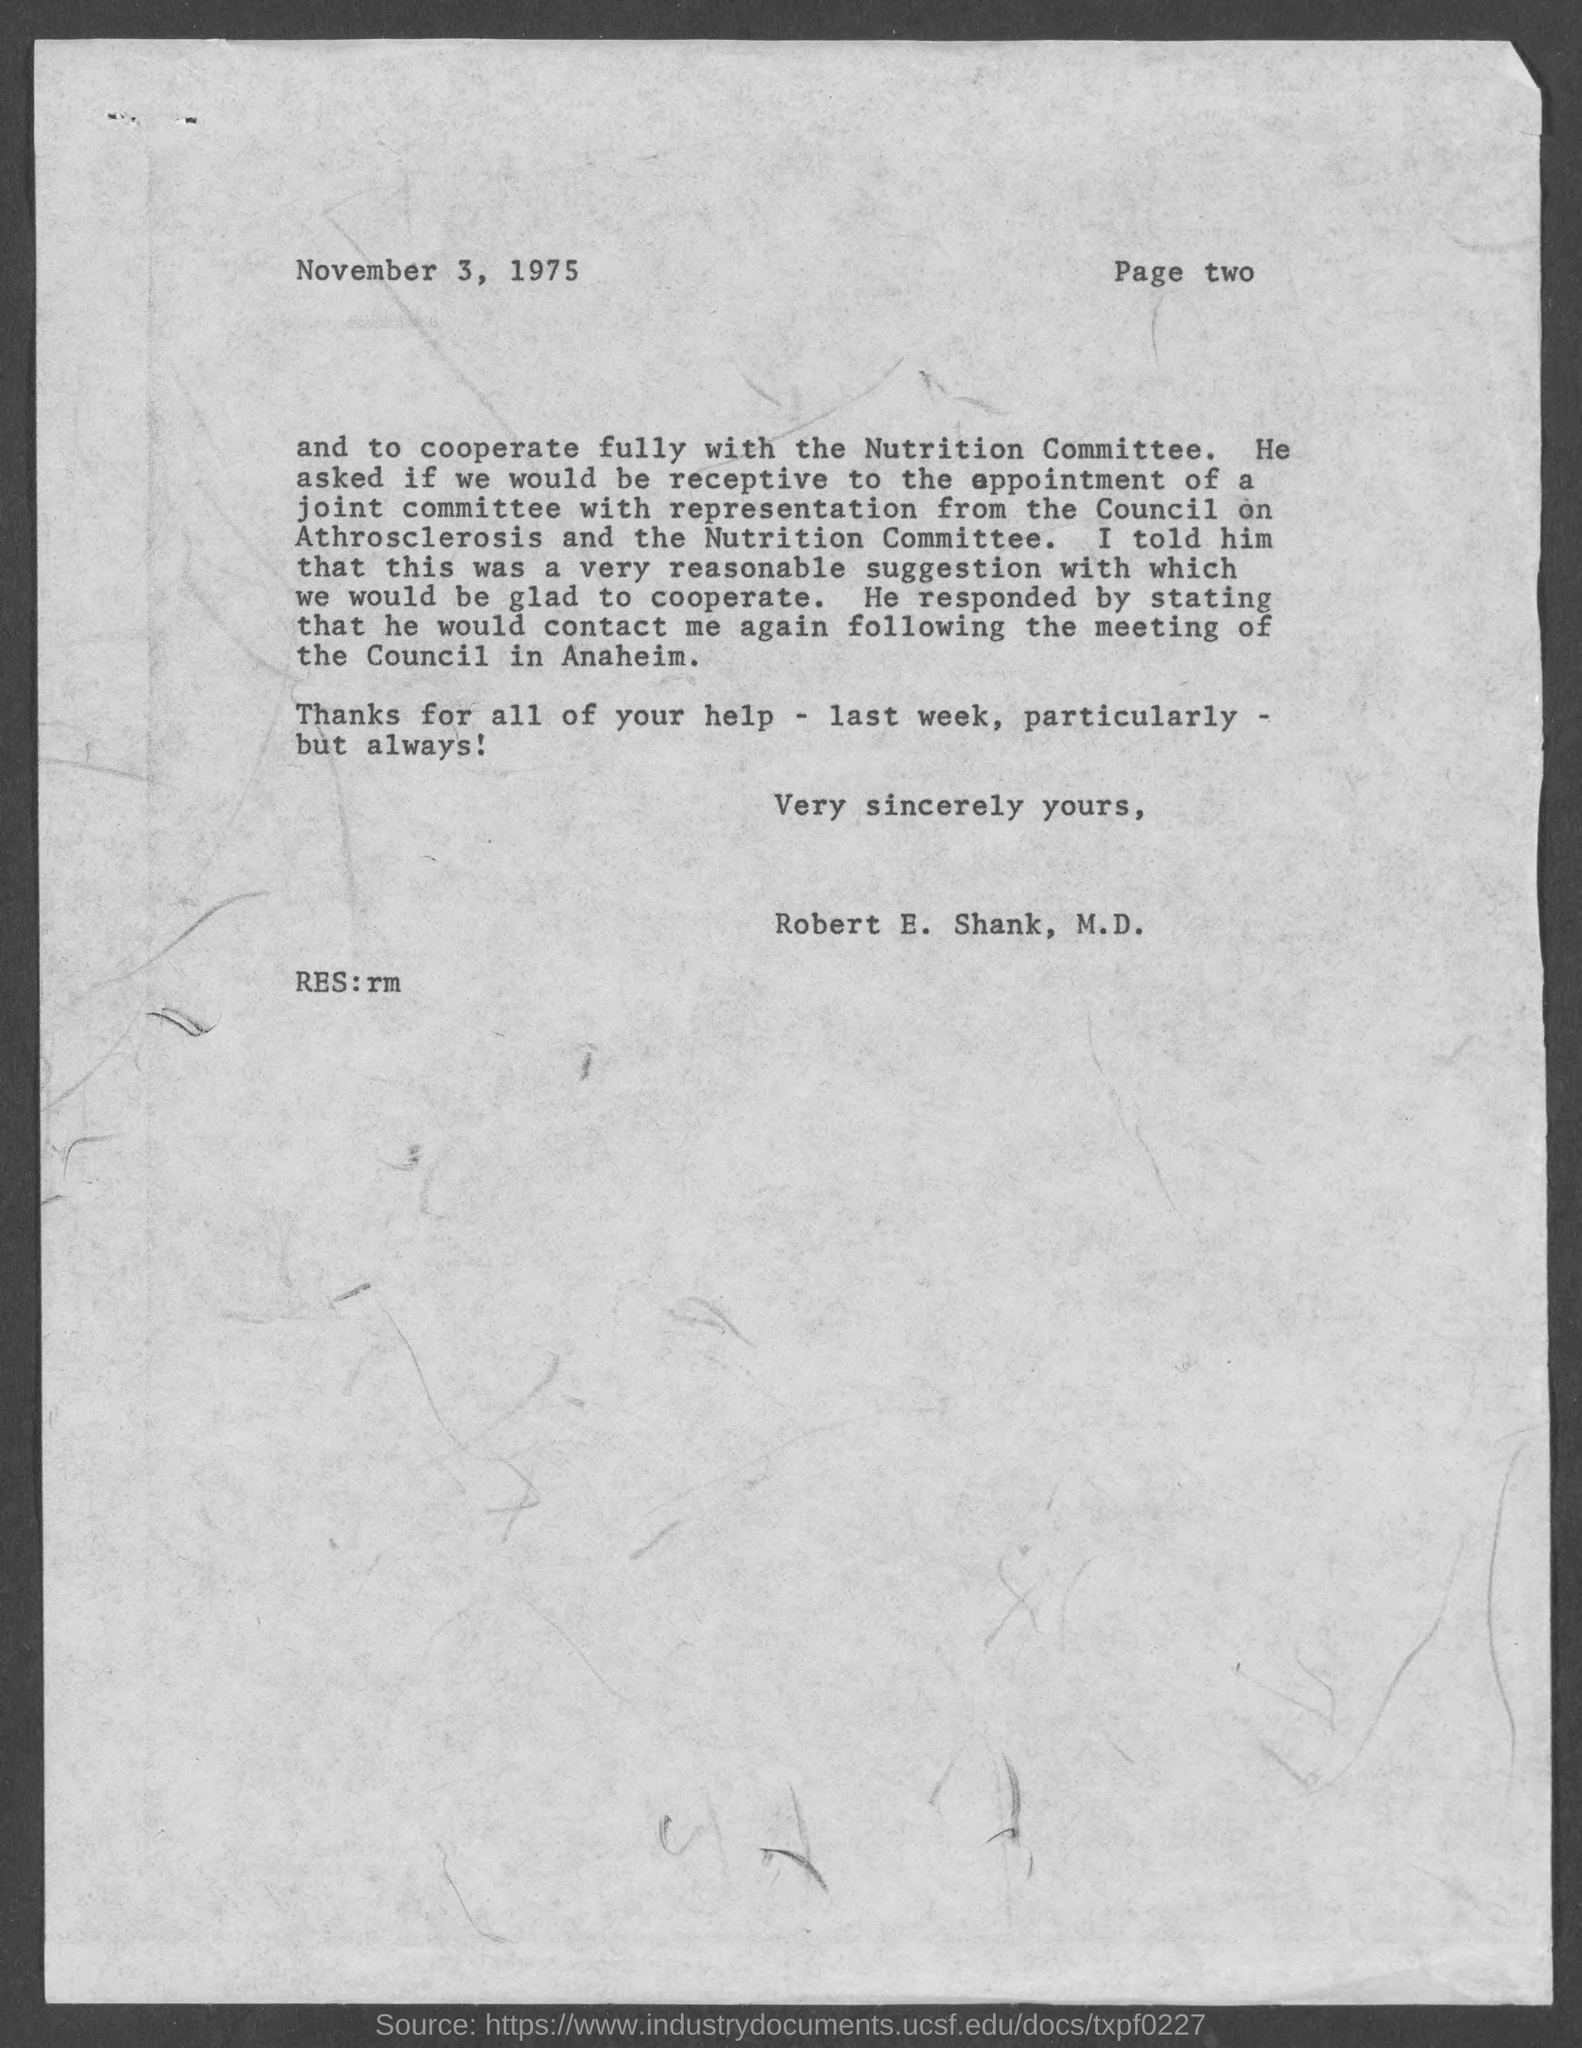Draw attention to some important aspects in this diagram. The letter is from Robert E. Shank, M.D. The document indicates that the date is November 3, 1975. 